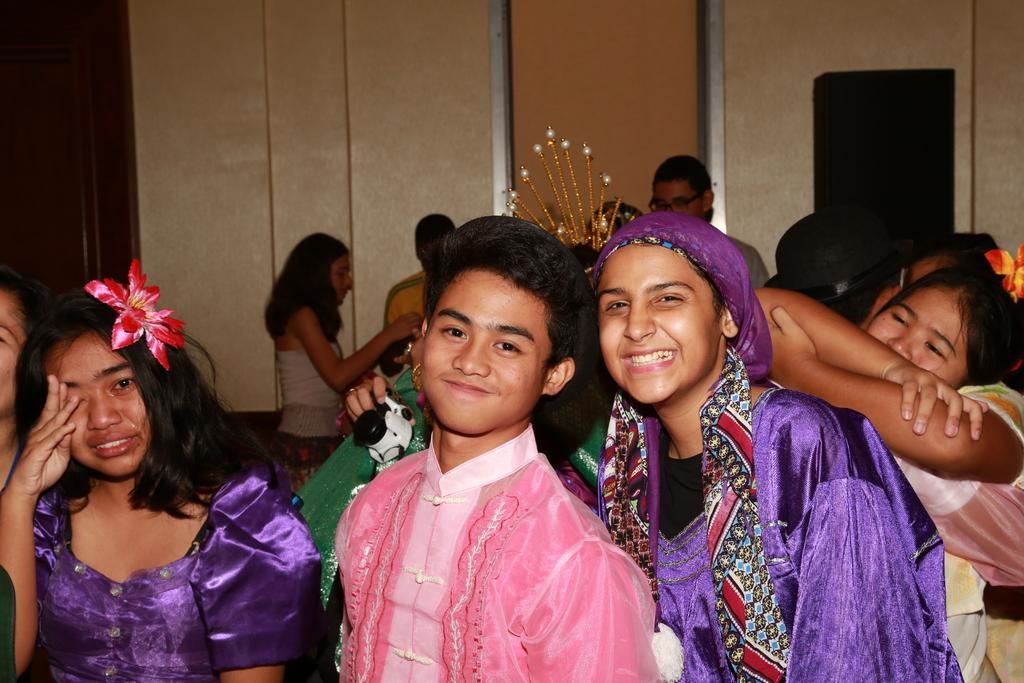Please provide a concise description of this image. In this image there are a few people standing with a smile on their face, one of them is crying and behind them there are a few more people standing. In the background there is a wall and a door. 